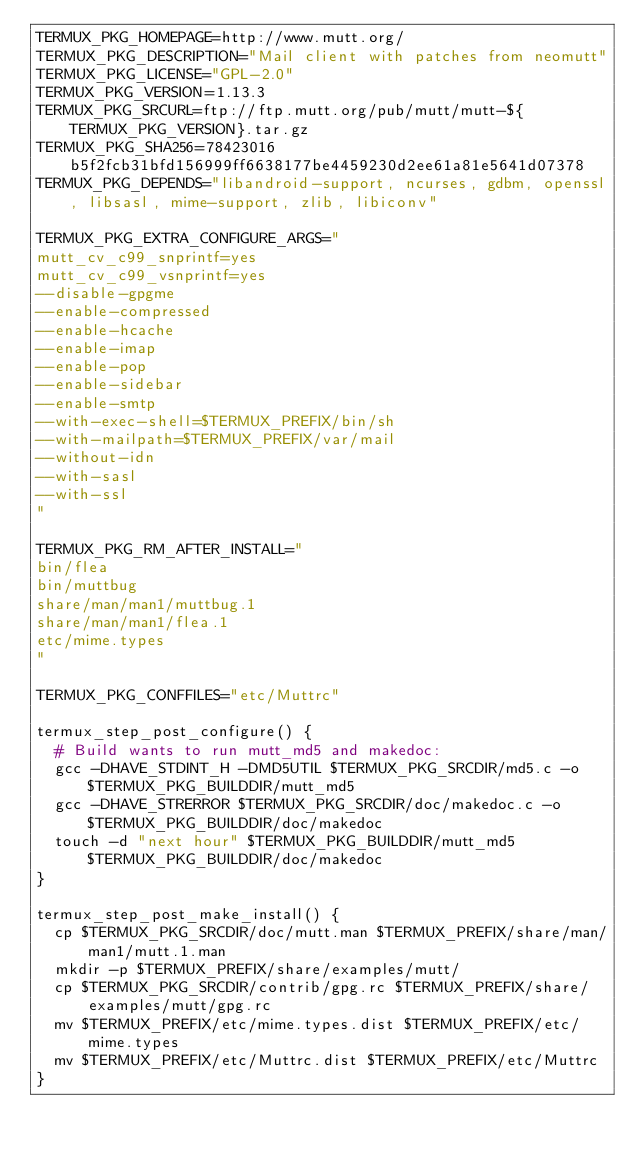<code> <loc_0><loc_0><loc_500><loc_500><_Bash_>TERMUX_PKG_HOMEPAGE=http://www.mutt.org/
TERMUX_PKG_DESCRIPTION="Mail client with patches from neomutt"
TERMUX_PKG_LICENSE="GPL-2.0"
TERMUX_PKG_VERSION=1.13.3
TERMUX_PKG_SRCURL=ftp://ftp.mutt.org/pub/mutt/mutt-${TERMUX_PKG_VERSION}.tar.gz
TERMUX_PKG_SHA256=78423016b5f2fcb31bfd156999ff6638177be4459230d2ee61a81e5641d07378
TERMUX_PKG_DEPENDS="libandroid-support, ncurses, gdbm, openssl, libsasl, mime-support, zlib, libiconv"

TERMUX_PKG_EXTRA_CONFIGURE_ARGS="
mutt_cv_c99_snprintf=yes
mutt_cv_c99_vsnprintf=yes
--disable-gpgme
--enable-compressed
--enable-hcache
--enable-imap
--enable-pop
--enable-sidebar
--enable-smtp
--with-exec-shell=$TERMUX_PREFIX/bin/sh
--with-mailpath=$TERMUX_PREFIX/var/mail
--without-idn
--with-sasl
--with-ssl
"

TERMUX_PKG_RM_AFTER_INSTALL="
bin/flea
bin/muttbug
share/man/man1/muttbug.1
share/man/man1/flea.1
etc/mime.types
"

TERMUX_PKG_CONFFILES="etc/Muttrc"

termux_step_post_configure() {
	# Build wants to run mutt_md5 and makedoc:
	gcc -DHAVE_STDINT_H -DMD5UTIL $TERMUX_PKG_SRCDIR/md5.c -o $TERMUX_PKG_BUILDDIR/mutt_md5
	gcc -DHAVE_STRERROR $TERMUX_PKG_SRCDIR/doc/makedoc.c -o $TERMUX_PKG_BUILDDIR/doc/makedoc
	touch -d "next hour" $TERMUX_PKG_BUILDDIR/mutt_md5 $TERMUX_PKG_BUILDDIR/doc/makedoc
}

termux_step_post_make_install() {
	cp $TERMUX_PKG_SRCDIR/doc/mutt.man $TERMUX_PREFIX/share/man/man1/mutt.1.man
	mkdir -p $TERMUX_PREFIX/share/examples/mutt/
	cp $TERMUX_PKG_SRCDIR/contrib/gpg.rc $TERMUX_PREFIX/share/examples/mutt/gpg.rc
	mv $TERMUX_PREFIX/etc/mime.types.dist $TERMUX_PREFIX/etc/mime.types
	mv $TERMUX_PREFIX/etc/Muttrc.dist $TERMUX_PREFIX/etc/Muttrc
}
</code> 